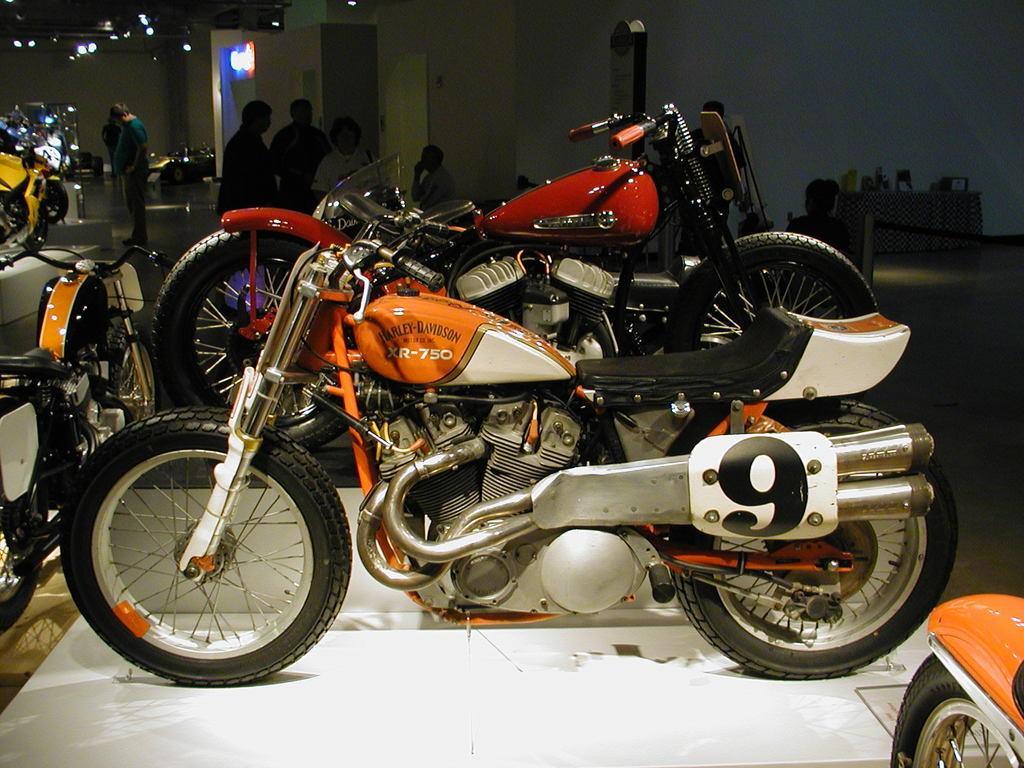How would you summarize this image in a sentence or two? In this image there are bikes. Behind the bikes there are few people. On top of the image there are lights. In the background of the image there is a wall. At the bottom of the image there is a floor. On the right side of the image there is a table and on top of the table there are few objects. 